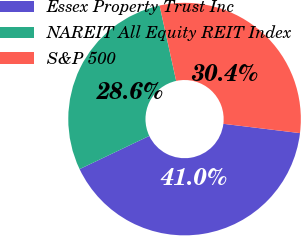Convert chart. <chart><loc_0><loc_0><loc_500><loc_500><pie_chart><fcel>Essex Property Trust Inc<fcel>NAREIT All Equity REIT Index<fcel>S&P 500<nl><fcel>41.0%<fcel>28.63%<fcel>30.37%<nl></chart> 